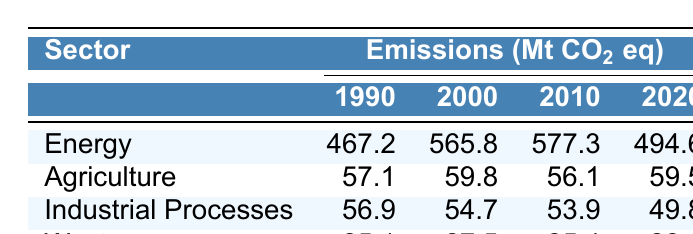What were the greenhouse gas emissions from the Energy sector in 2000? The table shows that the emissions from the Energy sector in 2000 were 565.8 Mt CO₂ eq.
Answer: 565.8 Which sector had the lowest emissions in 2010? The Industrial Processes sector emitted 53.9 Mt CO₂ eq in 2010, which is lower than any other sector listed for that year.
Answer: Industrial Processes What is the difference in emissions from the Waste sector between 1990 and 2020? The Waste sector emitted 25.1 Mt CO₂ eq in 1990 and 22.1 Mt CO₂ eq in 2020. The difference is 25.1 - 22.1 = 3.0 Mt CO₂ eq.
Answer: 3.0 What was the trend in emissions for the Energy sector from 1990 to 2020? The emissions from the Energy sector increased from 467.2 Mt CO₂ eq in 1990 to a peak of 577.3 Mt CO₂ eq in 2010, then decreased to 494.6 Mt CO₂ eq in 2020, indicating a fluctuation overall.
Answer: Fluctuating Which sector experienced the most significant percentage decrease in emissions from 2010 to 2020? The Industrial Processes sector decreased from 53.9 Mt CO₂ eq in 2010 to 49.8 Mt CO₂ eq in 2020. The percentage decrease is ((53.9-49.8)/53.9) * 100 = 7.6%. Checking other sectors shows that this is the most significant decrease among them.
Answer: Industrial Processes What are the total emissions from the Agriculture sector over the years measured? Summing the emissions from the Agriculture sector: 57.1 + 59.8 + 56.1 + 59.5 = 232.5 Mt CO₂ eq.
Answer: 232.5 Are emissions from the Agriculture sector consistent over the years? Reviewing the emissions values for Agriculture, which are 57.1, 59.8, 56.1, and 59.5 Mt CO₂ eq, there is some variation, predominantly around the mid-50s to 59, indicating relative consistency with minor fluctuations.
Answer: Yes Which sector showed a reduction in emissions between 2010 and 2020? The Industrial Processes and Waste sectors showed reductions in emissions, with Industrial Processes decreasing to 49.8 Mt CO₂ eq and Waste reducing to 22.1 Mt CO₂ eq. The others either increased or fluctuated.
Answer: Industrial Processes and Waste What is the average emission from the Energy sector over the four measured years? The emissions from the Energy sector are 467.2, 565.8, 577.3, and 494.6 Mt CO₂ eq. The sum is 467.2 + 565.8 + 577.3 + 494.6 = 2104.9. The average is 2104.9 / 4 = 526.225 Mt CO₂ eq.
Answer: 526.225 Which year had the highest emissions from the Waste sector? The Waste sector emitted 27.5 Mt CO₂ eq in 2000, which is higher than in 1990 (25.1), 2010 (25.4), and 2020 (22.1).
Answer: 2000 Did the overall emissions in the Industrial Processes sector decrease from 1990 to 2020? The emissions from Industrial Processes in 1990 were 56.9 Mt CO₂ eq, decreasing to 49.8 Mt CO₂ eq in 2020, confirming a decrease over this period.
Answer: Yes 